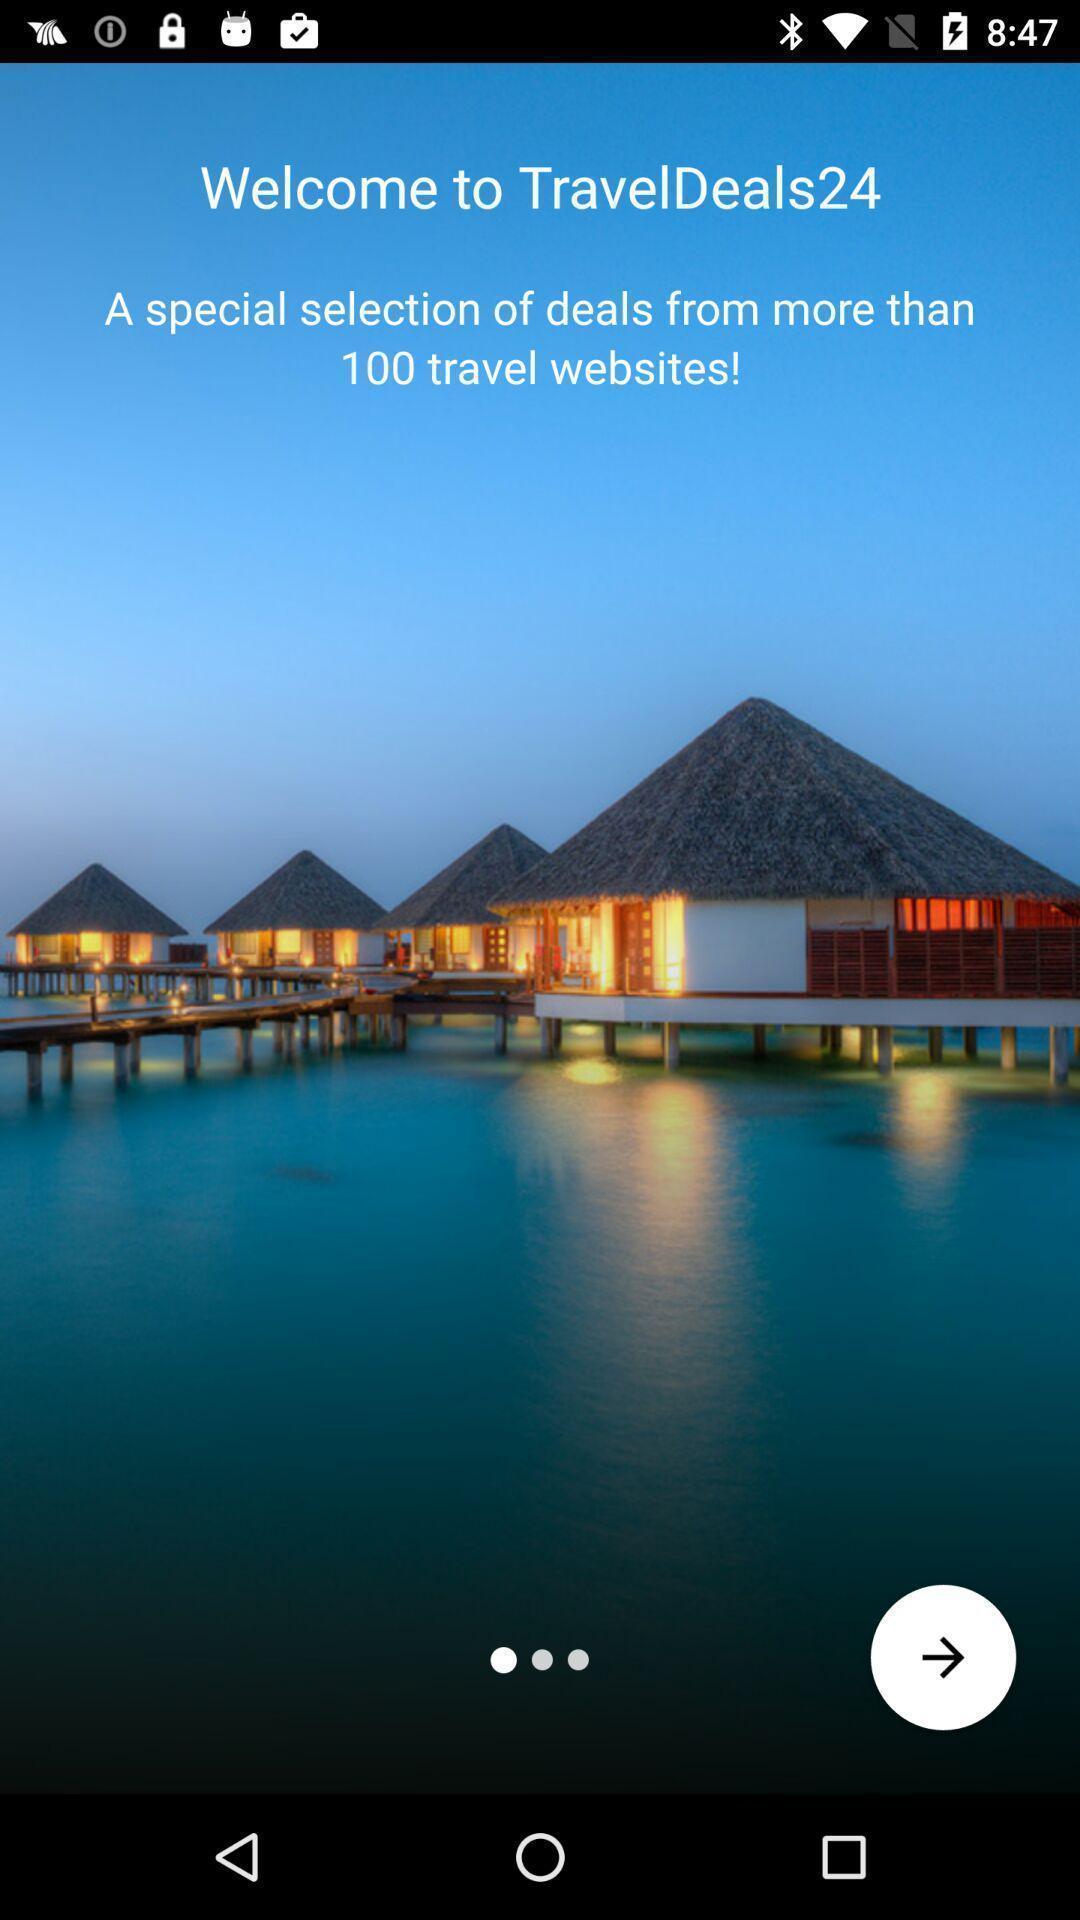Summarize the information in this screenshot. Welcome screen of travel app. 